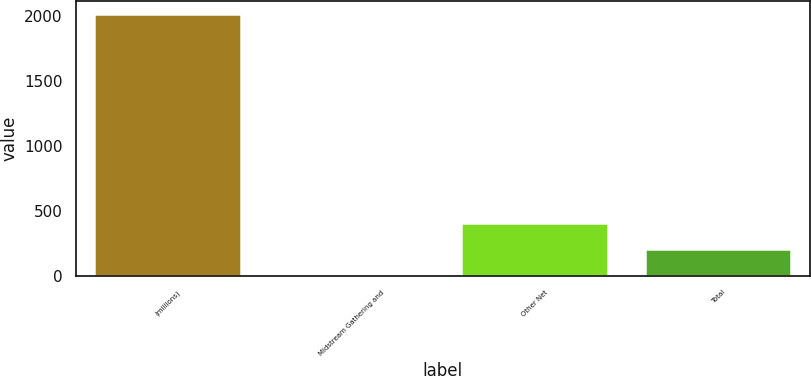Convert chart. <chart><loc_0><loc_0><loc_500><loc_500><bar_chart><fcel>(millions)<fcel>Midstream Gathering and<fcel>Other Net<fcel>Total<nl><fcel>2013<fcel>6<fcel>407.4<fcel>206.7<nl></chart> 